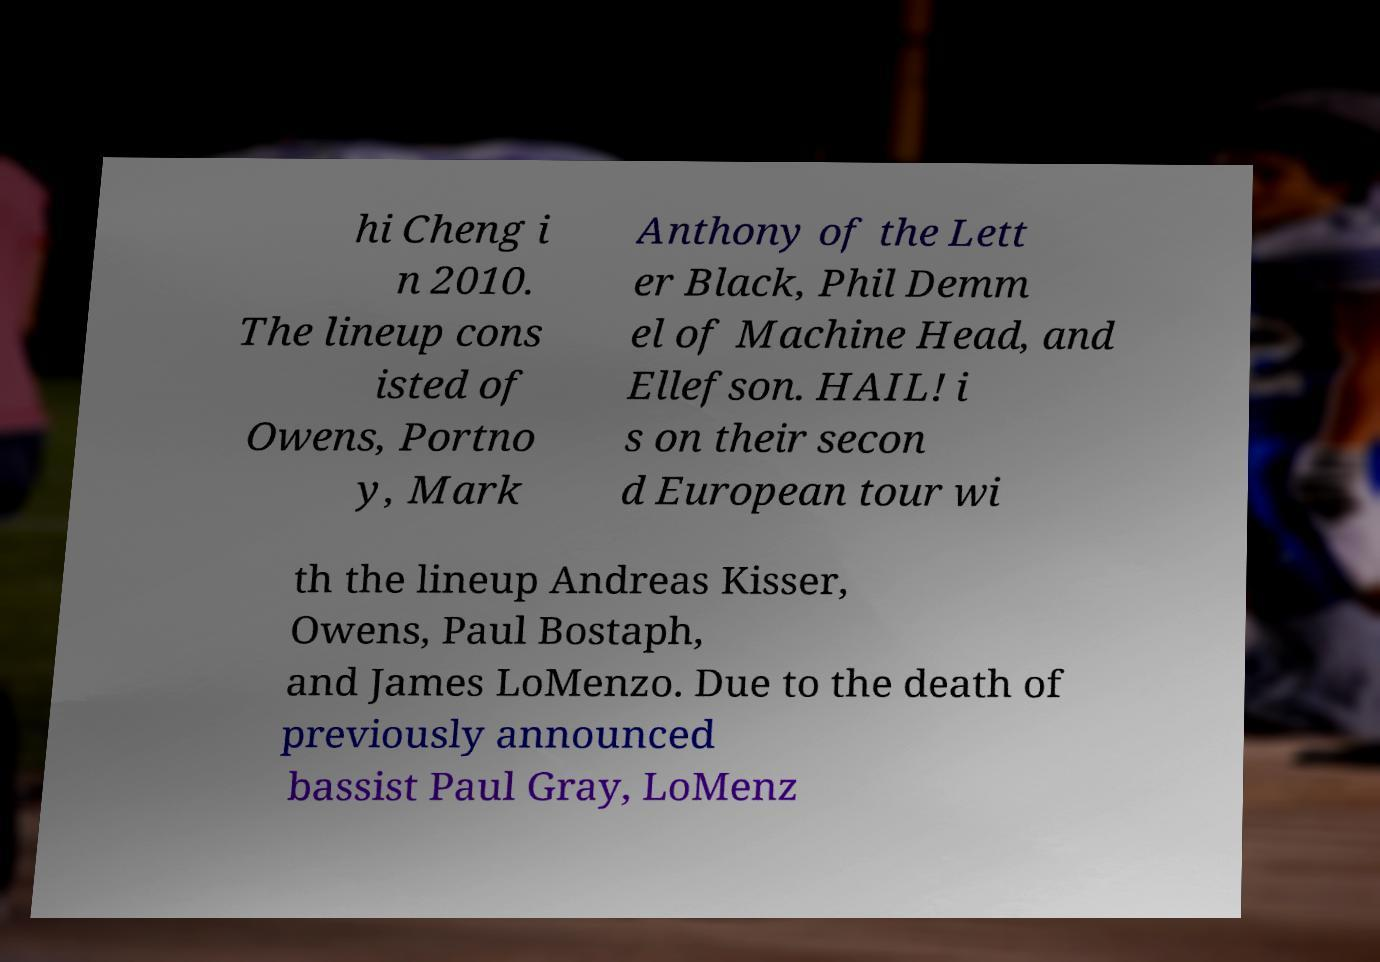What messages or text are displayed in this image? I need them in a readable, typed format. hi Cheng i n 2010. The lineup cons isted of Owens, Portno y, Mark Anthony of the Lett er Black, Phil Demm el of Machine Head, and Ellefson. HAIL! i s on their secon d European tour wi th the lineup Andreas Kisser, Owens, Paul Bostaph, and James LoMenzo. Due to the death of previously announced bassist Paul Gray, LoMenz 